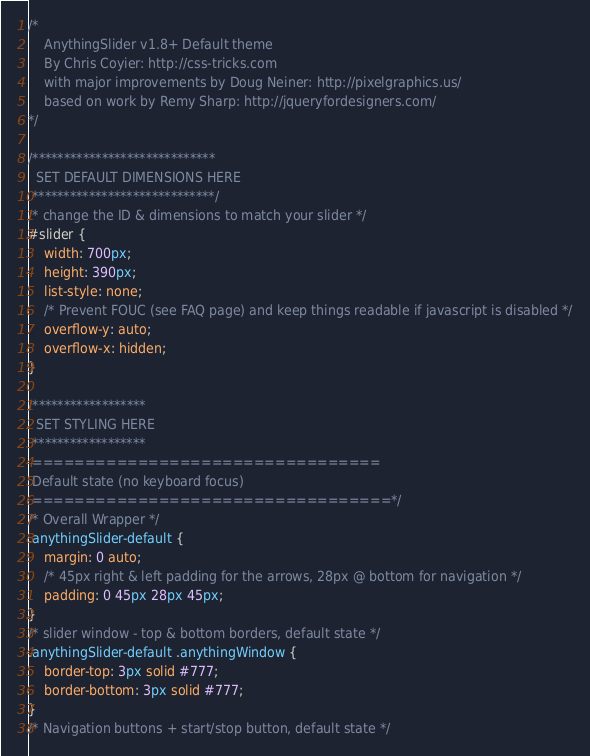Convert code to text. <code><loc_0><loc_0><loc_500><loc_500><_CSS_>/*
	AnythingSlider v1.8+ Default theme
	By Chris Coyier: http://css-tricks.com
	with major improvements by Doug Neiner: http://pixelgraphics.us/
	based on work by Remy Sharp: http://jqueryfordesigners.com/
*/

/*****************************
  SET DEFAULT DIMENSIONS HERE
 *****************************/
/* change the ID & dimensions to match your slider */
#slider {
	width: 700px;
	height: 390px;
	list-style: none;
	/* Prevent FOUC (see FAQ page) and keep things readable if javascript is disabled */
	overflow-y: auto;
	overflow-x: hidden;
}

/******************
  SET STYLING HERE
 ******************
 =================================
 Default state (no keyboard focus)
 ==================================*/
/* Overall Wrapper */
.anythingSlider-default {
	margin: 0 auto;
	/* 45px right & left padding for the arrows, 28px @ bottom for navigation */
	padding: 0 45px 28px 45px;
}
/* slider window - top & bottom borders, default state */
.anythingSlider-default .anythingWindow {
	border-top: 3px solid #777;
	border-bottom: 3px solid #777;
}
/* Navigation buttons + start/stop button, default state */</code> 